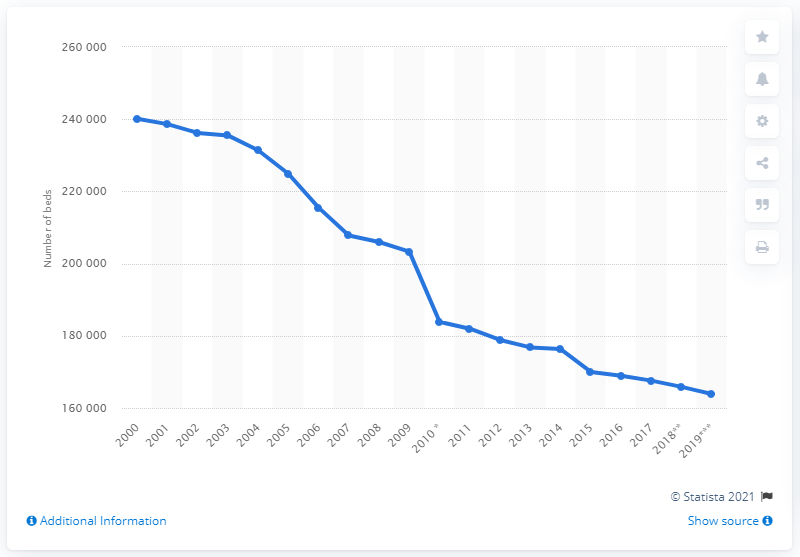Draw attention to some important aspects in this diagram. The number of hospital beds in the UK began to decline in the year 2000. In 2018, there were approximately 163,873 hospital beds in the United Kingdom. 